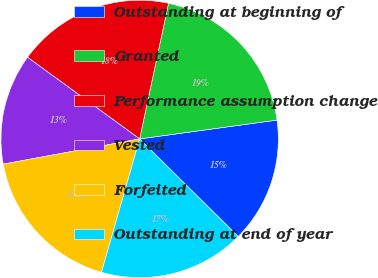Convert chart to OTSL. <chart><loc_0><loc_0><loc_500><loc_500><pie_chart><fcel>Outstanding at beginning of<fcel>Granted<fcel>Performance assumption change<fcel>Vested<fcel>Forfeited<fcel>Outstanding at end of year<nl><fcel>14.6%<fcel>19.49%<fcel>18.32%<fcel>12.93%<fcel>17.66%<fcel>17.0%<nl></chart> 